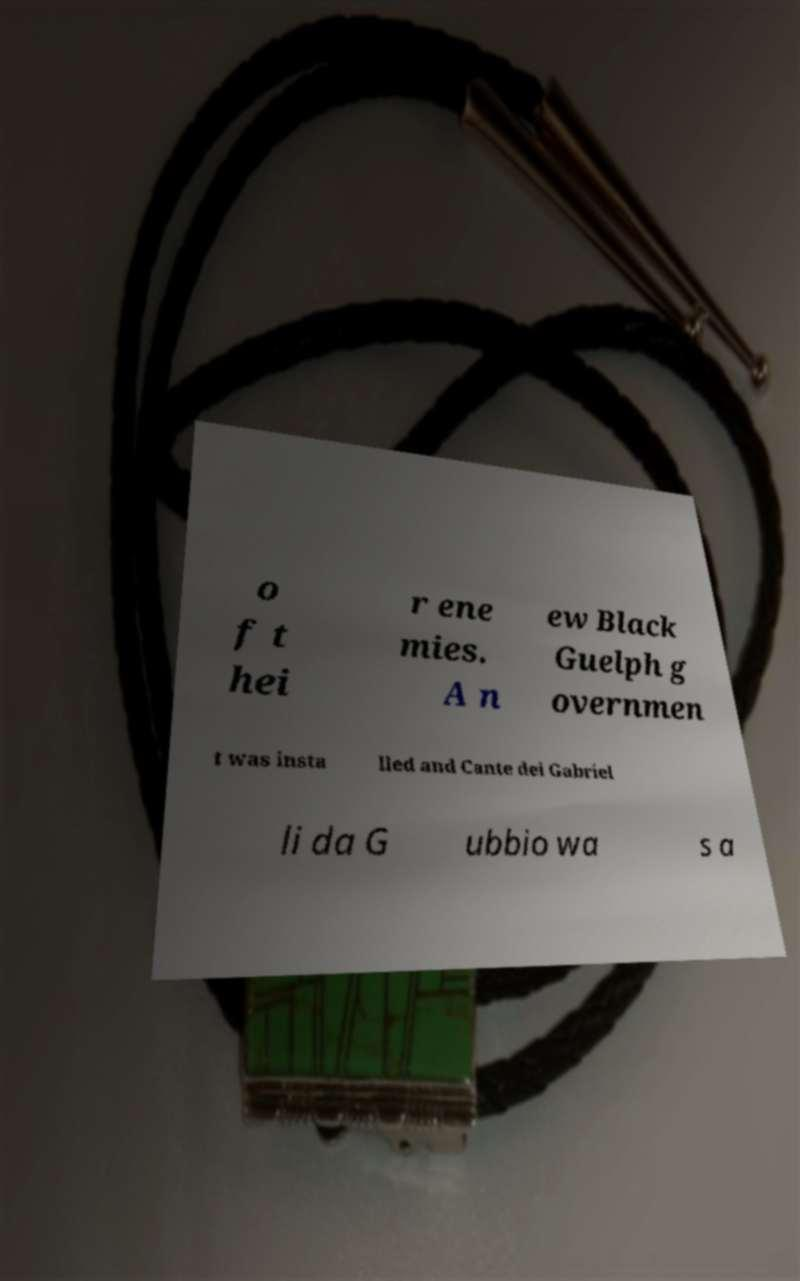Can you accurately transcribe the text from the provided image for me? o f t hei r ene mies. A n ew Black Guelph g overnmen t was insta lled and Cante dei Gabriel li da G ubbio wa s a 